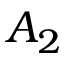<formula> <loc_0><loc_0><loc_500><loc_500>A _ { 2 }</formula> 